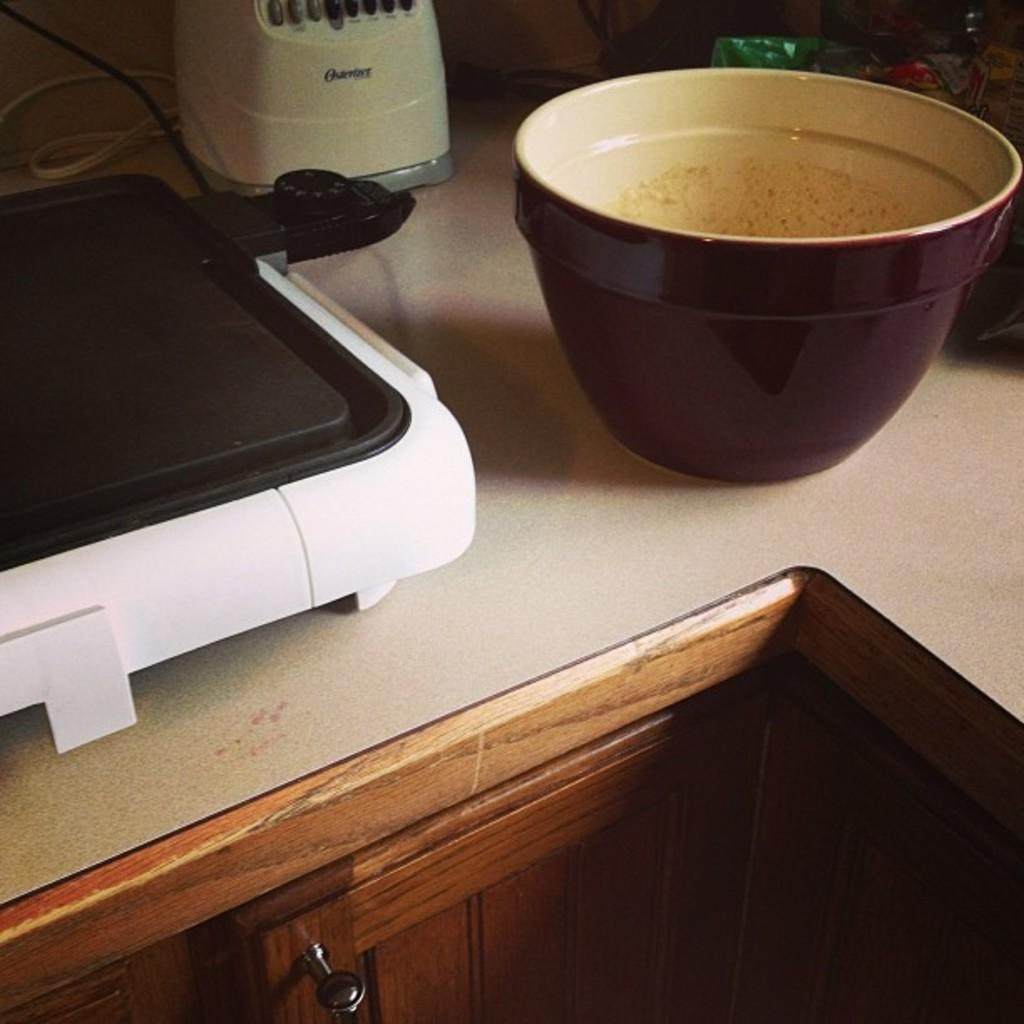<image>
Create a compact narrative representing the image presented. Large bowl in front of a machine that starts with the letter O. 